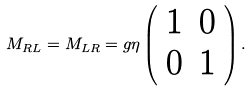Convert formula to latex. <formula><loc_0><loc_0><loc_500><loc_500>M _ { R L } = M _ { L R } = g \eta \left ( \begin{array} { c c } 1 & 0 \\ 0 & 1 \end{array} \right ) .</formula> 